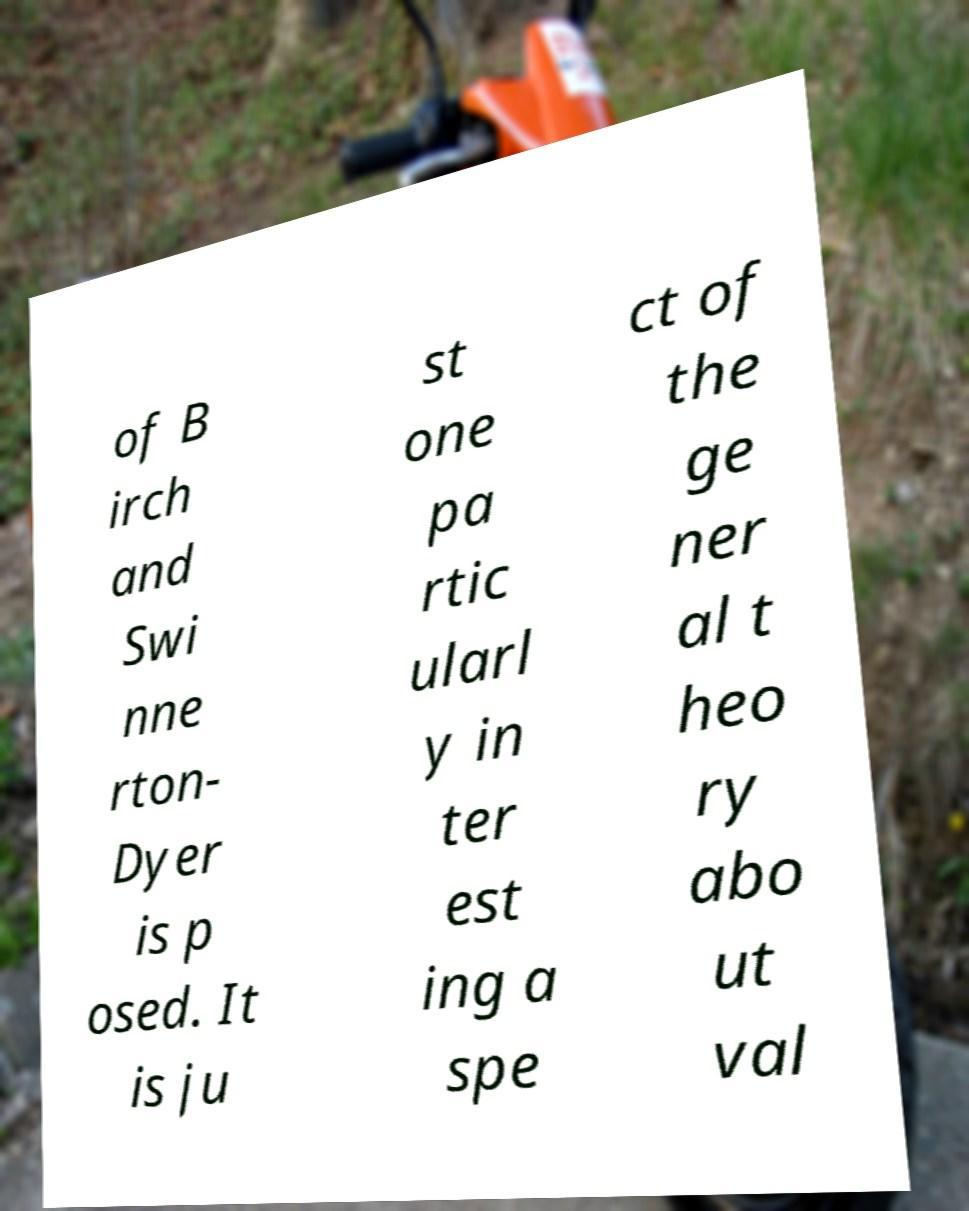Can you accurately transcribe the text from the provided image for me? of B irch and Swi nne rton- Dyer is p osed. It is ju st one pa rtic ularl y in ter est ing a spe ct of the ge ner al t heo ry abo ut val 